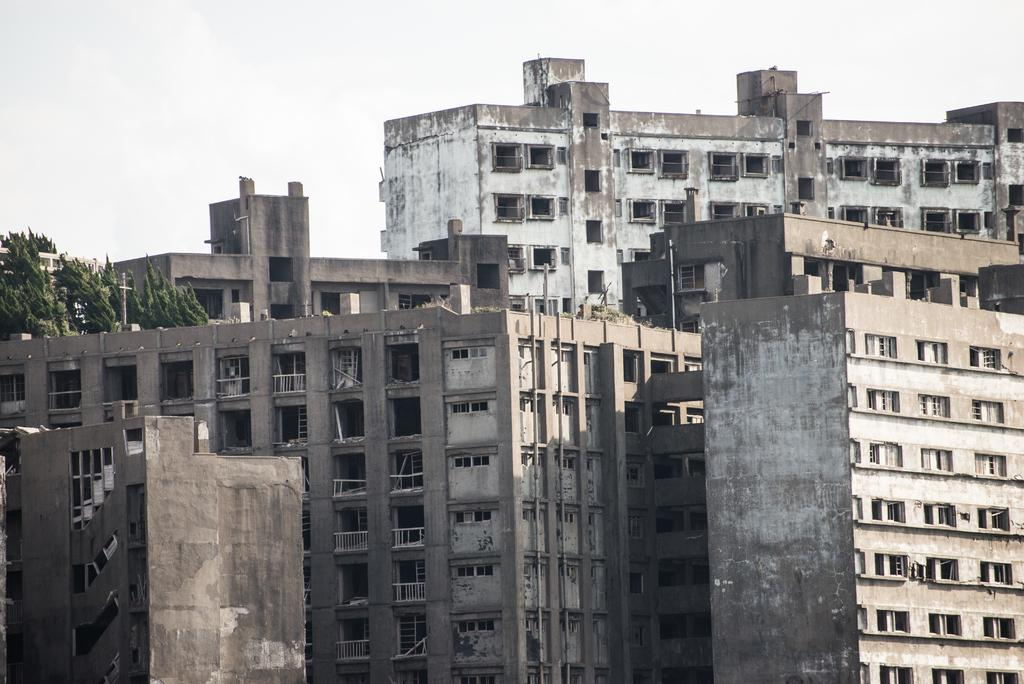What type of structures can be seen in the image? There are buildings in the image. What can be found on the left side of the image? There are trees on the left side of the image. What is visible in the background of the image? The sky is visible in the background of the image. What flavor of turkey is depicted in the image? There is no turkey present in the image, so it is not possible to determine its flavor. 